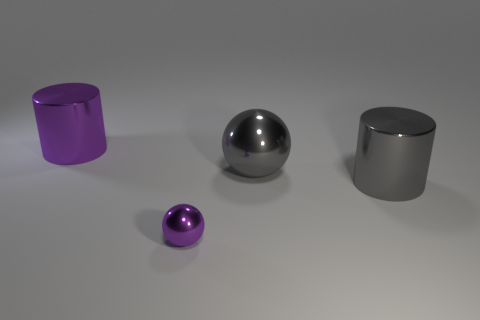Add 1 tiny shiny balls. How many objects exist? 5 Subtract all gray cylinders. How many cylinders are left? 1 Subtract 2 balls. How many balls are left? 0 Add 4 large metal things. How many large metal things exist? 7 Subtract 1 purple cylinders. How many objects are left? 3 Subtract all purple cylinders. Subtract all cyan balls. How many cylinders are left? 1 Subtract all purple spheres. How many purple cylinders are left? 1 Subtract all large shiny balls. Subtract all gray metal blocks. How many objects are left? 3 Add 1 small purple things. How many small purple things are left? 2 